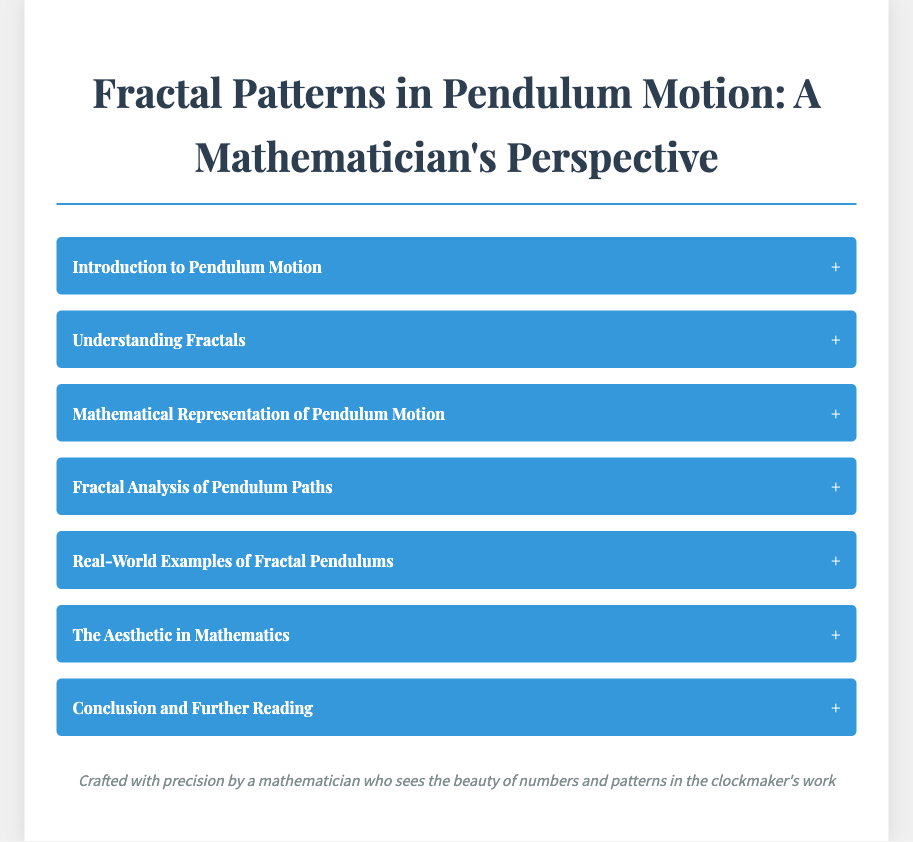What is the title of the document? The title of the document is found in the <title> tag at the top of the HTML, which states the main theme of the content.
Answer: Fractal Patterns in Pendulum Motion: A Mathematician's Perspective How many main sections are listed in the menu? The number of main sections is determined by counting the items in the menu list.
Answer: Seven What is the main focus of the section titled "Understanding Fractals"? The focus of this section is described in the menu item content that outlines the main themes of the section.
Answer: Infinite complexity and self-similarity Which mathematical concept is referenced in the section on Fractal Analysis? The specific mathematical concept mentioned in the content of the section about analyzing pendulum trajectories is crucial for understanding fractals.
Answer: Lyapunov exponent What artistic representation is mentioned in the section on Real-World Examples? The section refers to a specific type of pendulum which serves both artistic and scientific purposes, reflecting fractal properties.
Answer: Foucault Pendulum What is suggested in the conclusion for further exploration? The conclusion section typically provides guidance for additional resources or topics to explore related to the main document theme.
Answer: Additional resources for deeper exploration Which design element is used to enhance the aesthetic of the document? The design element is evident in the styles applied to the text and layout that create a pleasing visual experience.
Answer: Box-shadow 